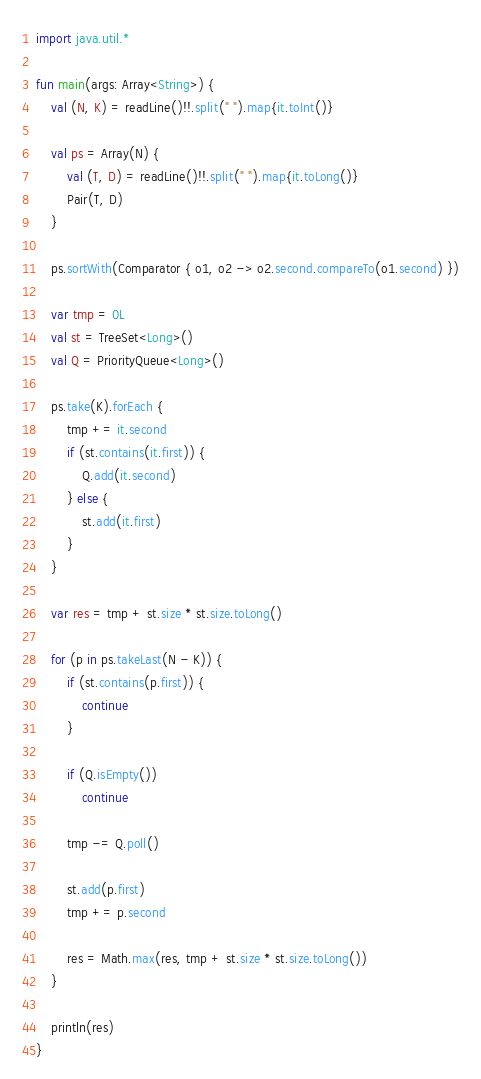Convert code to text. <code><loc_0><loc_0><loc_500><loc_500><_Kotlin_>import java.util.*

fun main(args: Array<String>) {
    val (N, K) = readLine()!!.split(" ").map{it.toInt()}

    val ps = Array(N) {
        val (T, D) = readLine()!!.split(" ").map{it.toLong()}
        Pair(T, D)
    }

    ps.sortWith(Comparator { o1, o2 -> o2.second.compareTo(o1.second) })

    var tmp = 0L
    val st = TreeSet<Long>()
    val Q = PriorityQueue<Long>()

    ps.take(K).forEach {
        tmp += it.second
        if (st.contains(it.first)) {
            Q.add(it.second)
        } else {
            st.add(it.first)
        }
    }

    var res = tmp + st.size * st.size.toLong()

    for (p in ps.takeLast(N - K)) {
        if (st.contains(p.first)) {
            continue
        }

        if (Q.isEmpty())
            continue

        tmp -= Q.poll()

        st.add(p.first)
        tmp += p.second

        res = Math.max(res, tmp + st.size * st.size.toLong())
    }

    println(res)
}
</code> 